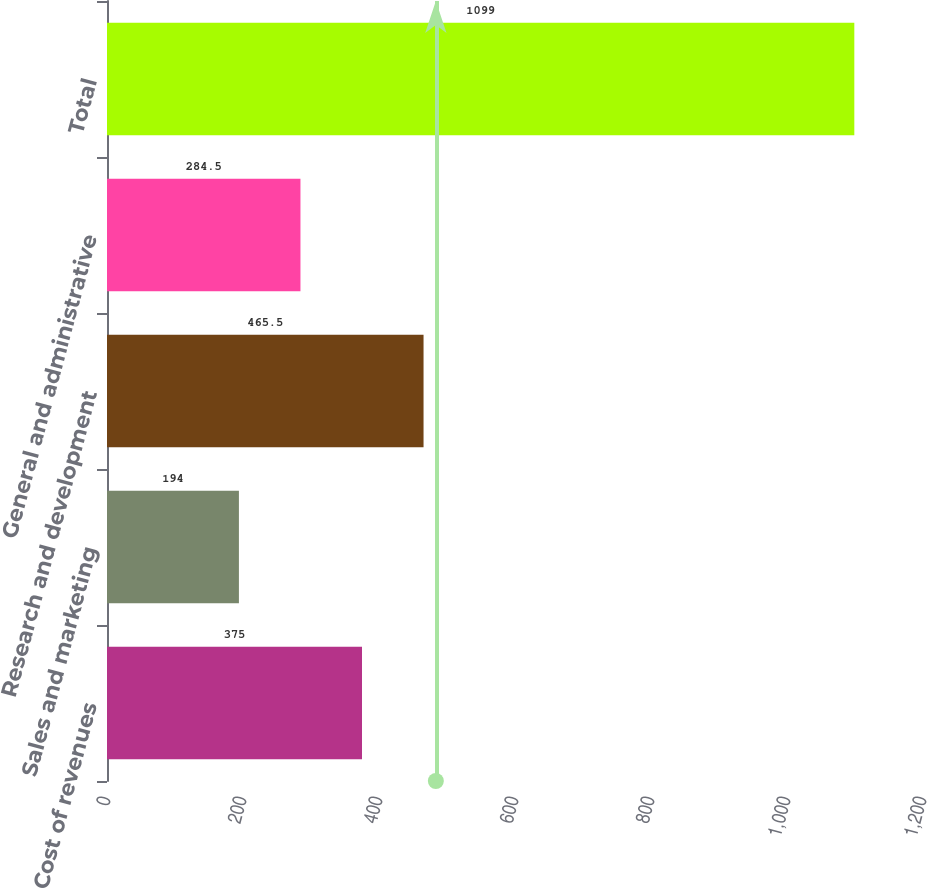Convert chart. <chart><loc_0><loc_0><loc_500><loc_500><bar_chart><fcel>Cost of revenues<fcel>Sales and marketing<fcel>Research and development<fcel>General and administrative<fcel>Total<nl><fcel>375<fcel>194<fcel>465.5<fcel>284.5<fcel>1099<nl></chart> 